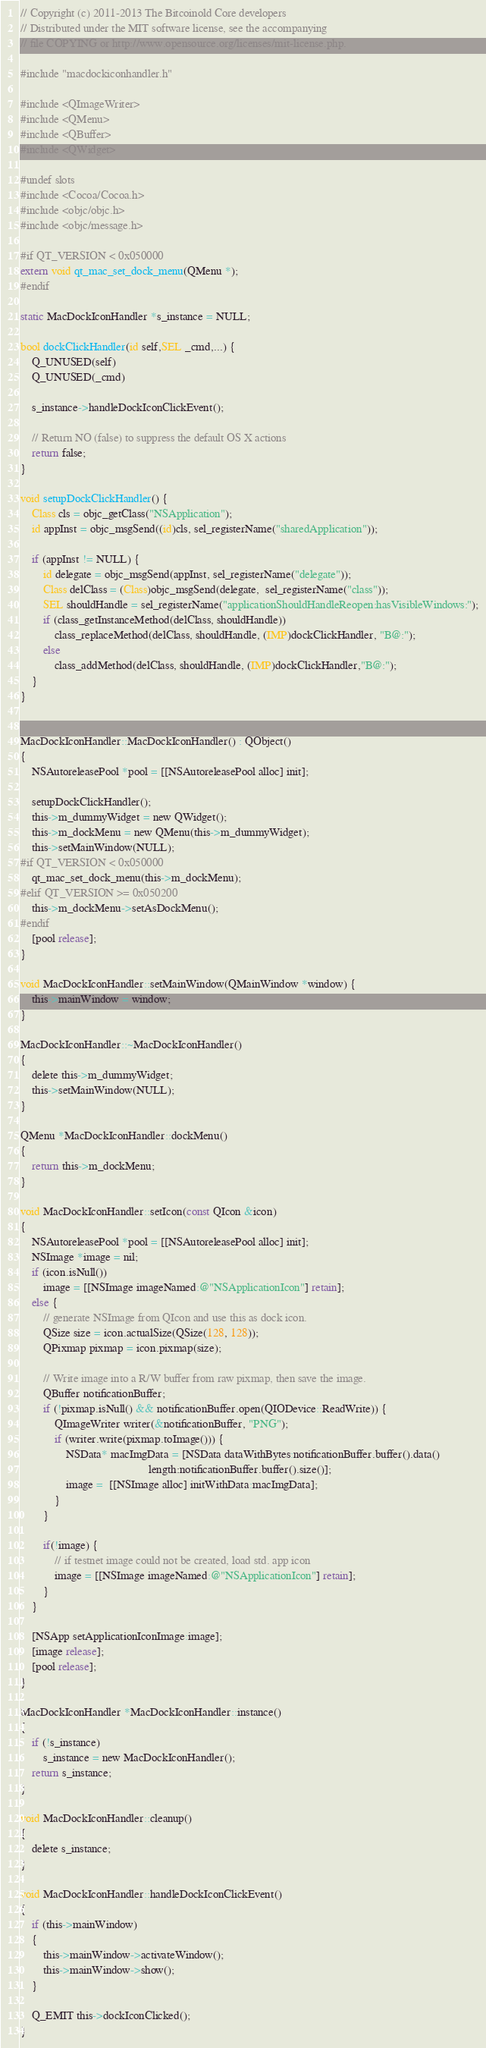Convert code to text. <code><loc_0><loc_0><loc_500><loc_500><_ObjectiveC_>// Copyright (c) 2011-2013 The Bitcoinold Core developers
// Distributed under the MIT software license, see the accompanying
// file COPYING or http://www.opensource.org/licenses/mit-license.php.

#include "macdockiconhandler.h"

#include <QImageWriter>
#include <QMenu>
#include <QBuffer>
#include <QWidget>

#undef slots
#include <Cocoa/Cocoa.h>
#include <objc/objc.h>
#include <objc/message.h>

#if QT_VERSION < 0x050000
extern void qt_mac_set_dock_menu(QMenu *);
#endif

static MacDockIconHandler *s_instance = NULL;

bool dockClickHandler(id self,SEL _cmd,...) {
    Q_UNUSED(self)
    Q_UNUSED(_cmd)
    
    s_instance->handleDockIconClickEvent();
    
    // Return NO (false) to suppress the default OS X actions
    return false;
}

void setupDockClickHandler() {
    Class cls = objc_getClass("NSApplication");
    id appInst = objc_msgSend((id)cls, sel_registerName("sharedApplication"));
    
    if (appInst != NULL) {
        id delegate = objc_msgSend(appInst, sel_registerName("delegate"));
        Class delClass = (Class)objc_msgSend(delegate,  sel_registerName("class"));
        SEL shouldHandle = sel_registerName("applicationShouldHandleReopen:hasVisibleWindows:");
        if (class_getInstanceMethod(delClass, shouldHandle))
            class_replaceMethod(delClass, shouldHandle, (IMP)dockClickHandler, "B@:");
        else
            class_addMethod(delClass, shouldHandle, (IMP)dockClickHandler,"B@:");
    }
}


MacDockIconHandler::MacDockIconHandler() : QObject()
{
    NSAutoreleasePool *pool = [[NSAutoreleasePool alloc] init];

    setupDockClickHandler();
    this->m_dummyWidget = new QWidget();
    this->m_dockMenu = new QMenu(this->m_dummyWidget);
    this->setMainWindow(NULL);
#if QT_VERSION < 0x050000
    qt_mac_set_dock_menu(this->m_dockMenu);
#elif QT_VERSION >= 0x050200
    this->m_dockMenu->setAsDockMenu();
#endif
    [pool release];
}

void MacDockIconHandler::setMainWindow(QMainWindow *window) {
    this->mainWindow = window;
}

MacDockIconHandler::~MacDockIconHandler()
{
    delete this->m_dummyWidget;
    this->setMainWindow(NULL);
}

QMenu *MacDockIconHandler::dockMenu()
{
    return this->m_dockMenu;
}

void MacDockIconHandler::setIcon(const QIcon &icon)
{
    NSAutoreleasePool *pool = [[NSAutoreleasePool alloc] init];
    NSImage *image = nil;
    if (icon.isNull())
        image = [[NSImage imageNamed:@"NSApplicationIcon"] retain];
    else {
        // generate NSImage from QIcon and use this as dock icon.
        QSize size = icon.actualSize(QSize(128, 128));
        QPixmap pixmap = icon.pixmap(size);

        // Write image into a R/W buffer from raw pixmap, then save the image.
        QBuffer notificationBuffer;
        if (!pixmap.isNull() && notificationBuffer.open(QIODevice::ReadWrite)) {
            QImageWriter writer(&notificationBuffer, "PNG");
            if (writer.write(pixmap.toImage())) {
                NSData* macImgData = [NSData dataWithBytes:notificationBuffer.buffer().data()
                                             length:notificationBuffer.buffer().size()];
                image =  [[NSImage alloc] initWithData:macImgData];
            }
        }

        if(!image) {
            // if testnet image could not be created, load std. app icon
            image = [[NSImage imageNamed:@"NSApplicationIcon"] retain];
        }
    }

    [NSApp setApplicationIconImage:image];
    [image release];
    [pool release];
}

MacDockIconHandler *MacDockIconHandler::instance()
{
    if (!s_instance)
        s_instance = new MacDockIconHandler();
    return s_instance;
}

void MacDockIconHandler::cleanup()
{
    delete s_instance;
}

void MacDockIconHandler::handleDockIconClickEvent()
{
    if (this->mainWindow)
    {
        this->mainWindow->activateWindow();
        this->mainWindow->show();
    }

    Q_EMIT this->dockIconClicked();
}
</code> 